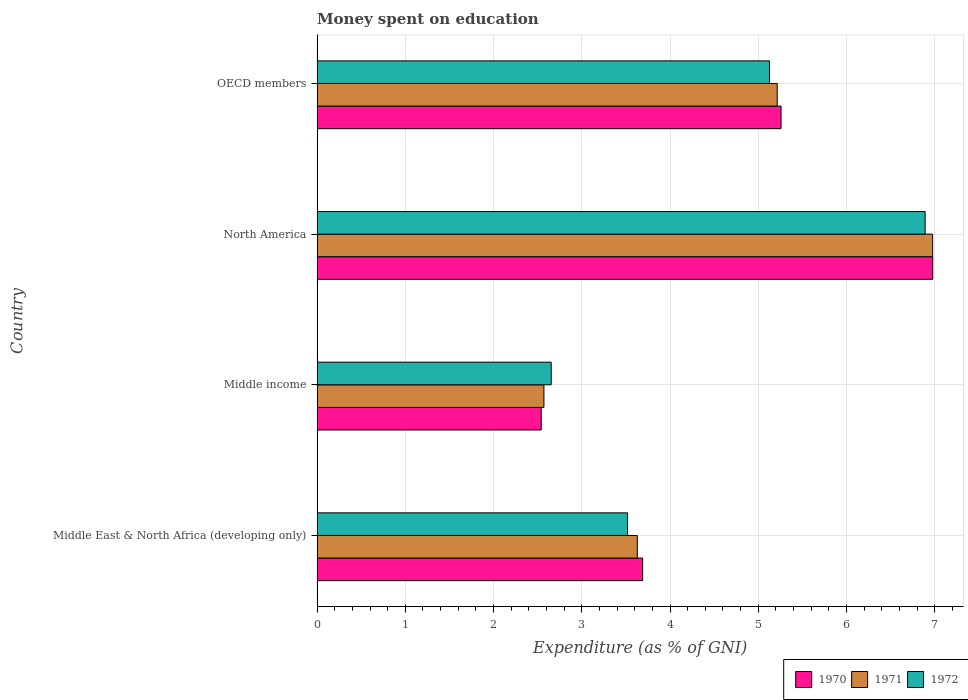How many groups of bars are there?
Your answer should be very brief. 4. Are the number of bars per tick equal to the number of legend labels?
Your answer should be very brief. Yes. Are the number of bars on each tick of the Y-axis equal?
Give a very brief answer. Yes. How many bars are there on the 2nd tick from the top?
Keep it short and to the point. 3. How many bars are there on the 4th tick from the bottom?
Your answer should be compact. 3. What is the label of the 4th group of bars from the top?
Keep it short and to the point. Middle East & North Africa (developing only). What is the amount of money spent on education in 1970 in Middle income?
Make the answer very short. 2.54. Across all countries, what is the maximum amount of money spent on education in 1970?
Keep it short and to the point. 6.98. Across all countries, what is the minimum amount of money spent on education in 1971?
Make the answer very short. 2.57. In which country was the amount of money spent on education in 1972 maximum?
Provide a succinct answer. North America. What is the total amount of money spent on education in 1970 in the graph?
Make the answer very short. 18.47. What is the difference between the amount of money spent on education in 1972 in Middle East & North Africa (developing only) and that in North America?
Your response must be concise. -3.37. What is the difference between the amount of money spent on education in 1970 in North America and the amount of money spent on education in 1971 in Middle East & North Africa (developing only)?
Make the answer very short. 3.35. What is the average amount of money spent on education in 1972 per country?
Your answer should be compact. 4.55. What is the difference between the amount of money spent on education in 1970 and amount of money spent on education in 1972 in Middle income?
Keep it short and to the point. -0.11. In how many countries, is the amount of money spent on education in 1970 greater than 2.4 %?
Provide a short and direct response. 4. What is the ratio of the amount of money spent on education in 1971 in North America to that in OECD members?
Your answer should be compact. 1.34. Is the amount of money spent on education in 1971 in Middle East & North Africa (developing only) less than that in North America?
Provide a short and direct response. Yes. What is the difference between the highest and the second highest amount of money spent on education in 1970?
Make the answer very short. 1.72. What is the difference between the highest and the lowest amount of money spent on education in 1972?
Give a very brief answer. 4.24. In how many countries, is the amount of money spent on education in 1970 greater than the average amount of money spent on education in 1970 taken over all countries?
Provide a short and direct response. 2. Is the sum of the amount of money spent on education in 1972 in North America and OECD members greater than the maximum amount of money spent on education in 1971 across all countries?
Your response must be concise. Yes. What does the 3rd bar from the top in OECD members represents?
Ensure brevity in your answer.  1970. How many bars are there?
Make the answer very short. 12. Does the graph contain any zero values?
Your answer should be very brief. No. Does the graph contain grids?
Keep it short and to the point. Yes. How many legend labels are there?
Make the answer very short. 3. What is the title of the graph?
Make the answer very short. Money spent on education. What is the label or title of the X-axis?
Keep it short and to the point. Expenditure (as % of GNI). What is the Expenditure (as % of GNI) of 1970 in Middle East & North Africa (developing only)?
Offer a terse response. 3.69. What is the Expenditure (as % of GNI) of 1971 in Middle East & North Africa (developing only)?
Ensure brevity in your answer.  3.63. What is the Expenditure (as % of GNI) of 1972 in Middle East & North Africa (developing only)?
Offer a terse response. 3.52. What is the Expenditure (as % of GNI) in 1970 in Middle income?
Your response must be concise. 2.54. What is the Expenditure (as % of GNI) of 1971 in Middle income?
Keep it short and to the point. 2.57. What is the Expenditure (as % of GNI) in 1972 in Middle income?
Ensure brevity in your answer.  2.65. What is the Expenditure (as % of GNI) in 1970 in North America?
Keep it short and to the point. 6.98. What is the Expenditure (as % of GNI) in 1971 in North America?
Offer a terse response. 6.98. What is the Expenditure (as % of GNI) of 1972 in North America?
Your answer should be very brief. 6.89. What is the Expenditure (as % of GNI) in 1970 in OECD members?
Your response must be concise. 5.26. What is the Expenditure (as % of GNI) of 1971 in OECD members?
Offer a very short reply. 5.21. What is the Expenditure (as % of GNI) of 1972 in OECD members?
Make the answer very short. 5.13. Across all countries, what is the maximum Expenditure (as % of GNI) of 1970?
Your response must be concise. 6.98. Across all countries, what is the maximum Expenditure (as % of GNI) of 1971?
Your answer should be compact. 6.98. Across all countries, what is the maximum Expenditure (as % of GNI) in 1972?
Your response must be concise. 6.89. Across all countries, what is the minimum Expenditure (as % of GNI) in 1970?
Make the answer very short. 2.54. Across all countries, what is the minimum Expenditure (as % of GNI) of 1971?
Ensure brevity in your answer.  2.57. Across all countries, what is the minimum Expenditure (as % of GNI) in 1972?
Make the answer very short. 2.65. What is the total Expenditure (as % of GNI) of 1970 in the graph?
Offer a very short reply. 18.47. What is the total Expenditure (as % of GNI) of 1971 in the graph?
Offer a very short reply. 18.39. What is the total Expenditure (as % of GNI) of 1972 in the graph?
Offer a terse response. 18.19. What is the difference between the Expenditure (as % of GNI) in 1970 in Middle East & North Africa (developing only) and that in Middle income?
Provide a short and direct response. 1.15. What is the difference between the Expenditure (as % of GNI) of 1971 in Middle East & North Africa (developing only) and that in Middle income?
Provide a succinct answer. 1.06. What is the difference between the Expenditure (as % of GNI) in 1972 in Middle East & North Africa (developing only) and that in Middle income?
Offer a very short reply. 0.86. What is the difference between the Expenditure (as % of GNI) of 1970 in Middle East & North Africa (developing only) and that in North America?
Offer a very short reply. -3.29. What is the difference between the Expenditure (as % of GNI) in 1971 in Middle East & North Africa (developing only) and that in North America?
Provide a short and direct response. -3.35. What is the difference between the Expenditure (as % of GNI) of 1972 in Middle East & North Africa (developing only) and that in North America?
Provide a succinct answer. -3.37. What is the difference between the Expenditure (as % of GNI) in 1970 in Middle East & North Africa (developing only) and that in OECD members?
Provide a succinct answer. -1.57. What is the difference between the Expenditure (as % of GNI) in 1971 in Middle East & North Africa (developing only) and that in OECD members?
Ensure brevity in your answer.  -1.59. What is the difference between the Expenditure (as % of GNI) of 1972 in Middle East & North Africa (developing only) and that in OECD members?
Your response must be concise. -1.61. What is the difference between the Expenditure (as % of GNI) of 1970 in Middle income and that in North America?
Provide a succinct answer. -4.44. What is the difference between the Expenditure (as % of GNI) in 1971 in Middle income and that in North America?
Your answer should be very brief. -4.41. What is the difference between the Expenditure (as % of GNI) of 1972 in Middle income and that in North America?
Your answer should be compact. -4.24. What is the difference between the Expenditure (as % of GNI) of 1970 in Middle income and that in OECD members?
Make the answer very short. -2.72. What is the difference between the Expenditure (as % of GNI) in 1971 in Middle income and that in OECD members?
Provide a succinct answer. -2.64. What is the difference between the Expenditure (as % of GNI) in 1972 in Middle income and that in OECD members?
Offer a very short reply. -2.47. What is the difference between the Expenditure (as % of GNI) of 1970 in North America and that in OECD members?
Provide a succinct answer. 1.72. What is the difference between the Expenditure (as % of GNI) of 1971 in North America and that in OECD members?
Provide a succinct answer. 1.76. What is the difference between the Expenditure (as % of GNI) of 1972 in North America and that in OECD members?
Your answer should be very brief. 1.76. What is the difference between the Expenditure (as % of GNI) in 1970 in Middle East & North Africa (developing only) and the Expenditure (as % of GNI) in 1971 in Middle income?
Your response must be concise. 1.12. What is the difference between the Expenditure (as % of GNI) in 1970 in Middle East & North Africa (developing only) and the Expenditure (as % of GNI) in 1972 in Middle income?
Provide a short and direct response. 1.04. What is the difference between the Expenditure (as % of GNI) in 1971 in Middle East & North Africa (developing only) and the Expenditure (as % of GNI) in 1972 in Middle income?
Your answer should be compact. 0.98. What is the difference between the Expenditure (as % of GNI) in 1970 in Middle East & North Africa (developing only) and the Expenditure (as % of GNI) in 1971 in North America?
Provide a short and direct response. -3.29. What is the difference between the Expenditure (as % of GNI) of 1970 in Middle East & North Africa (developing only) and the Expenditure (as % of GNI) of 1972 in North America?
Offer a very short reply. -3.2. What is the difference between the Expenditure (as % of GNI) in 1971 in Middle East & North Africa (developing only) and the Expenditure (as % of GNI) in 1972 in North America?
Your response must be concise. -3.26. What is the difference between the Expenditure (as % of GNI) of 1970 in Middle East & North Africa (developing only) and the Expenditure (as % of GNI) of 1971 in OECD members?
Your answer should be compact. -1.52. What is the difference between the Expenditure (as % of GNI) of 1970 in Middle East & North Africa (developing only) and the Expenditure (as % of GNI) of 1972 in OECD members?
Give a very brief answer. -1.44. What is the difference between the Expenditure (as % of GNI) in 1971 in Middle East & North Africa (developing only) and the Expenditure (as % of GNI) in 1972 in OECD members?
Ensure brevity in your answer.  -1.5. What is the difference between the Expenditure (as % of GNI) in 1970 in Middle income and the Expenditure (as % of GNI) in 1971 in North America?
Provide a short and direct response. -4.44. What is the difference between the Expenditure (as % of GNI) of 1970 in Middle income and the Expenditure (as % of GNI) of 1972 in North America?
Offer a very short reply. -4.35. What is the difference between the Expenditure (as % of GNI) in 1971 in Middle income and the Expenditure (as % of GNI) in 1972 in North America?
Your answer should be compact. -4.32. What is the difference between the Expenditure (as % of GNI) in 1970 in Middle income and the Expenditure (as % of GNI) in 1971 in OECD members?
Give a very brief answer. -2.67. What is the difference between the Expenditure (as % of GNI) in 1970 in Middle income and the Expenditure (as % of GNI) in 1972 in OECD members?
Offer a very short reply. -2.59. What is the difference between the Expenditure (as % of GNI) in 1971 in Middle income and the Expenditure (as % of GNI) in 1972 in OECD members?
Make the answer very short. -2.56. What is the difference between the Expenditure (as % of GNI) in 1970 in North America and the Expenditure (as % of GNI) in 1971 in OECD members?
Provide a short and direct response. 1.76. What is the difference between the Expenditure (as % of GNI) in 1970 in North America and the Expenditure (as % of GNI) in 1972 in OECD members?
Make the answer very short. 1.85. What is the difference between the Expenditure (as % of GNI) in 1971 in North America and the Expenditure (as % of GNI) in 1972 in OECD members?
Provide a succinct answer. 1.85. What is the average Expenditure (as % of GNI) of 1970 per country?
Offer a terse response. 4.62. What is the average Expenditure (as % of GNI) in 1971 per country?
Offer a terse response. 4.6. What is the average Expenditure (as % of GNI) of 1972 per country?
Keep it short and to the point. 4.55. What is the difference between the Expenditure (as % of GNI) of 1970 and Expenditure (as % of GNI) of 1971 in Middle East & North Africa (developing only)?
Your answer should be compact. 0.06. What is the difference between the Expenditure (as % of GNI) of 1970 and Expenditure (as % of GNI) of 1972 in Middle East & North Africa (developing only)?
Make the answer very short. 0.17. What is the difference between the Expenditure (as % of GNI) in 1971 and Expenditure (as % of GNI) in 1972 in Middle East & North Africa (developing only)?
Offer a terse response. 0.11. What is the difference between the Expenditure (as % of GNI) of 1970 and Expenditure (as % of GNI) of 1971 in Middle income?
Make the answer very short. -0.03. What is the difference between the Expenditure (as % of GNI) of 1970 and Expenditure (as % of GNI) of 1972 in Middle income?
Your answer should be very brief. -0.11. What is the difference between the Expenditure (as % of GNI) of 1971 and Expenditure (as % of GNI) of 1972 in Middle income?
Your answer should be very brief. -0.08. What is the difference between the Expenditure (as % of GNI) of 1970 and Expenditure (as % of GNI) of 1971 in North America?
Give a very brief answer. 0. What is the difference between the Expenditure (as % of GNI) of 1970 and Expenditure (as % of GNI) of 1972 in North America?
Your response must be concise. 0.09. What is the difference between the Expenditure (as % of GNI) in 1971 and Expenditure (as % of GNI) in 1972 in North America?
Ensure brevity in your answer.  0.08. What is the difference between the Expenditure (as % of GNI) of 1970 and Expenditure (as % of GNI) of 1971 in OECD members?
Provide a short and direct response. 0.04. What is the difference between the Expenditure (as % of GNI) of 1970 and Expenditure (as % of GNI) of 1972 in OECD members?
Make the answer very short. 0.13. What is the difference between the Expenditure (as % of GNI) in 1971 and Expenditure (as % of GNI) in 1972 in OECD members?
Provide a short and direct response. 0.09. What is the ratio of the Expenditure (as % of GNI) of 1970 in Middle East & North Africa (developing only) to that in Middle income?
Keep it short and to the point. 1.45. What is the ratio of the Expenditure (as % of GNI) in 1971 in Middle East & North Africa (developing only) to that in Middle income?
Offer a very short reply. 1.41. What is the ratio of the Expenditure (as % of GNI) of 1972 in Middle East & North Africa (developing only) to that in Middle income?
Provide a short and direct response. 1.33. What is the ratio of the Expenditure (as % of GNI) in 1970 in Middle East & North Africa (developing only) to that in North America?
Your answer should be compact. 0.53. What is the ratio of the Expenditure (as % of GNI) of 1971 in Middle East & North Africa (developing only) to that in North America?
Offer a terse response. 0.52. What is the ratio of the Expenditure (as % of GNI) of 1972 in Middle East & North Africa (developing only) to that in North America?
Provide a succinct answer. 0.51. What is the ratio of the Expenditure (as % of GNI) of 1970 in Middle East & North Africa (developing only) to that in OECD members?
Offer a very short reply. 0.7. What is the ratio of the Expenditure (as % of GNI) in 1971 in Middle East & North Africa (developing only) to that in OECD members?
Give a very brief answer. 0.7. What is the ratio of the Expenditure (as % of GNI) in 1972 in Middle East & North Africa (developing only) to that in OECD members?
Ensure brevity in your answer.  0.69. What is the ratio of the Expenditure (as % of GNI) in 1970 in Middle income to that in North America?
Make the answer very short. 0.36. What is the ratio of the Expenditure (as % of GNI) of 1971 in Middle income to that in North America?
Offer a terse response. 0.37. What is the ratio of the Expenditure (as % of GNI) of 1972 in Middle income to that in North America?
Make the answer very short. 0.39. What is the ratio of the Expenditure (as % of GNI) in 1970 in Middle income to that in OECD members?
Offer a very short reply. 0.48. What is the ratio of the Expenditure (as % of GNI) of 1971 in Middle income to that in OECD members?
Your response must be concise. 0.49. What is the ratio of the Expenditure (as % of GNI) in 1972 in Middle income to that in OECD members?
Ensure brevity in your answer.  0.52. What is the ratio of the Expenditure (as % of GNI) in 1970 in North America to that in OECD members?
Make the answer very short. 1.33. What is the ratio of the Expenditure (as % of GNI) of 1971 in North America to that in OECD members?
Give a very brief answer. 1.34. What is the ratio of the Expenditure (as % of GNI) of 1972 in North America to that in OECD members?
Ensure brevity in your answer.  1.34. What is the difference between the highest and the second highest Expenditure (as % of GNI) of 1970?
Keep it short and to the point. 1.72. What is the difference between the highest and the second highest Expenditure (as % of GNI) of 1971?
Give a very brief answer. 1.76. What is the difference between the highest and the second highest Expenditure (as % of GNI) in 1972?
Offer a terse response. 1.76. What is the difference between the highest and the lowest Expenditure (as % of GNI) in 1970?
Provide a short and direct response. 4.44. What is the difference between the highest and the lowest Expenditure (as % of GNI) of 1971?
Ensure brevity in your answer.  4.41. What is the difference between the highest and the lowest Expenditure (as % of GNI) of 1972?
Give a very brief answer. 4.24. 